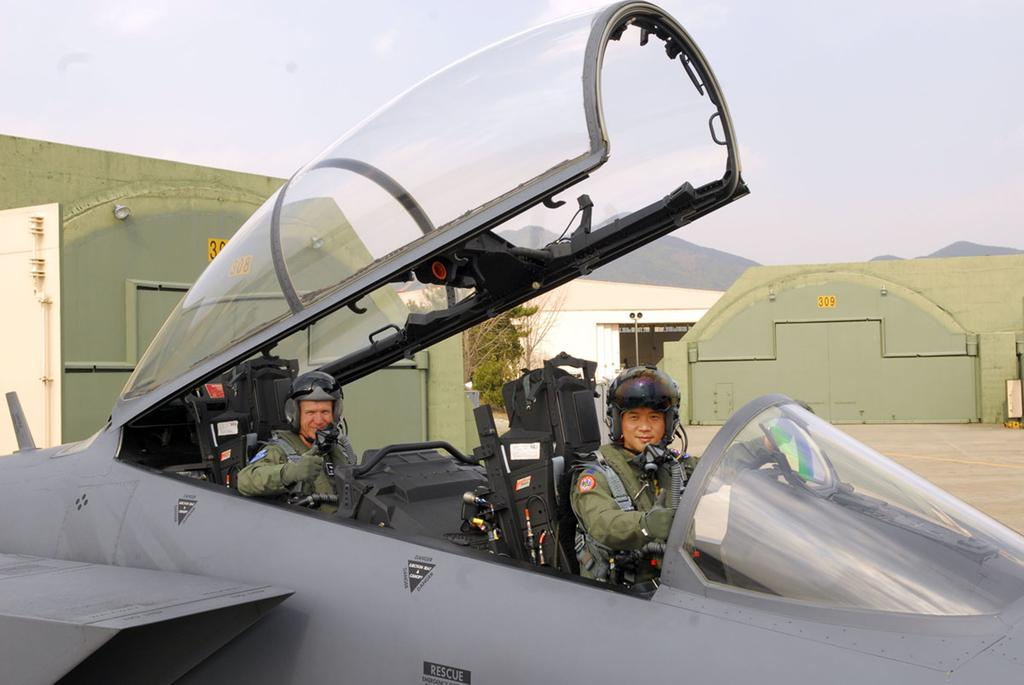Provide a one-sentence caption for the provided image. Two pilots sit in the open cockpit of a rescue plane. 